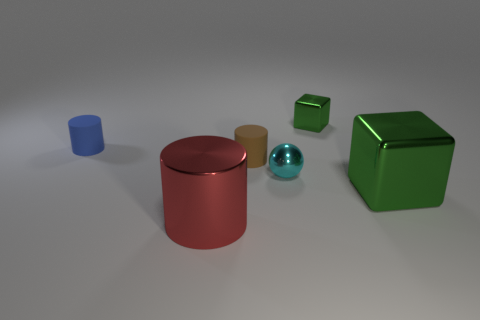Subtract all small cylinders. How many cylinders are left? 1 Add 3 tiny rubber things. How many objects exist? 9 Subtract all blue cylinders. How many cylinders are left? 2 Subtract all blocks. How many objects are left? 4 Add 6 tiny yellow shiny cylinders. How many tiny yellow shiny cylinders exist? 6 Subtract 1 red cylinders. How many objects are left? 5 Subtract 1 balls. How many balls are left? 0 Subtract all yellow cylinders. Subtract all cyan cubes. How many cylinders are left? 3 Subtract all large green metal objects. Subtract all tiny green objects. How many objects are left? 4 Add 3 blue objects. How many blue objects are left? 4 